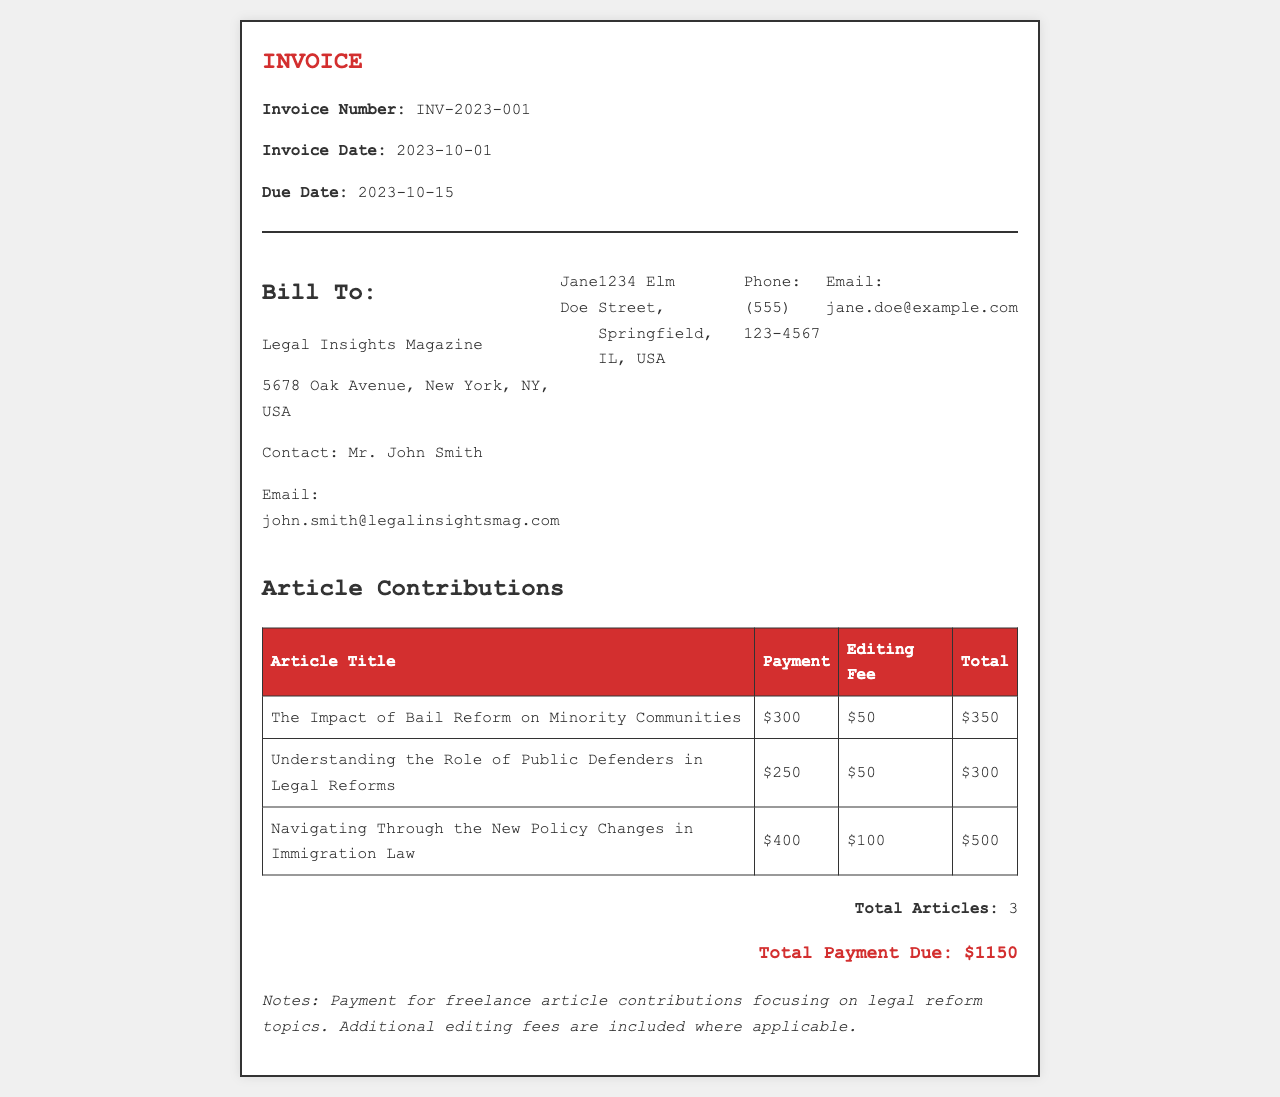What is the invoice number? The invoice number is listed at the top of the document under the header section.
Answer: INV-2023-001 What is the total payment due? The total payment due is calculated by adding all contributions and fees together, shown at the bottom of the summary section.
Answer: $1150 Who is the client for this invoice? The client details are provided in the 'Bill To' section of the invoice.
Answer: Legal Insights Magazine What is the editing fee for the first article? The editing fee is specified in the table under the 'Editing Fee' column for each article.
Answer: $50 How many articles are listed in this invoice? The total number of articles is mentioned in the summary section.
Answer: 3 What is the payment for the article titled "Understanding the Role of Public Defenders in Legal Reforms"? The payment for each article is specified in the 'Payment' column of the table.
Answer: $250 What is the due date for the payment? The due date is shown in the header section of the invoice, indicating when the payment should be made.
Answer: 2023-10-15 What additional note is provided regarding the payment? The invoice includes a notes section that describes the nature of the payment and any fees.
Answer: Payment for freelance article contributions focusing on legal reform topics 